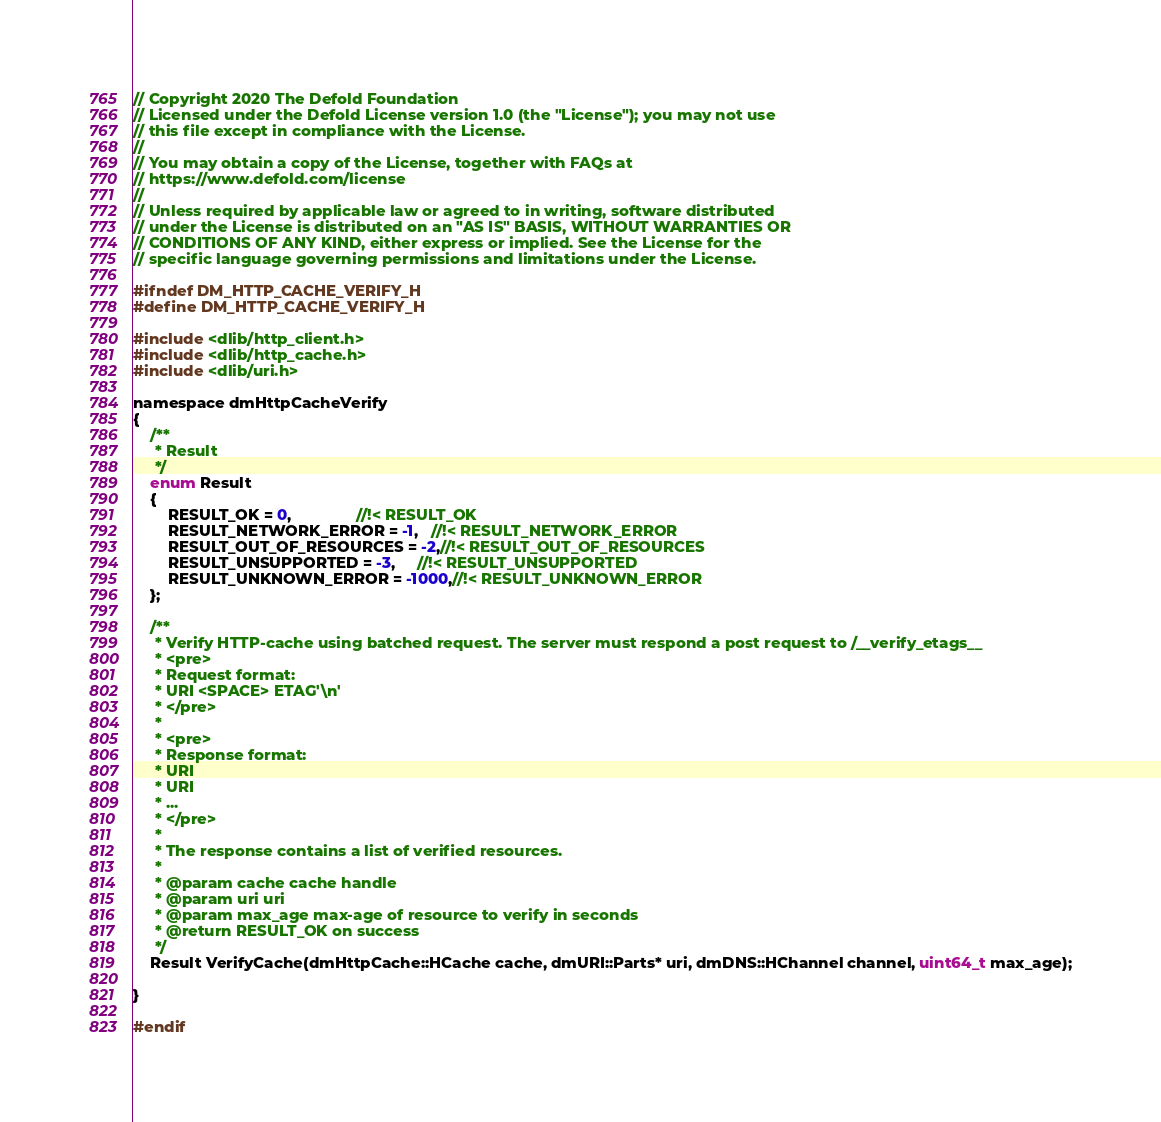<code> <loc_0><loc_0><loc_500><loc_500><_C_>// Copyright 2020 The Defold Foundation
// Licensed under the Defold License version 1.0 (the "License"); you may not use
// this file except in compliance with the License.
// 
// You may obtain a copy of the License, together with FAQs at
// https://www.defold.com/license
// 
// Unless required by applicable law or agreed to in writing, software distributed
// under the License is distributed on an "AS IS" BASIS, WITHOUT WARRANTIES OR
// CONDITIONS OF ANY KIND, either express or implied. See the License for the
// specific language governing permissions and limitations under the License.

#ifndef DM_HTTP_CACHE_VERIFY_H
#define DM_HTTP_CACHE_VERIFY_H

#include <dlib/http_client.h>
#include <dlib/http_cache.h>
#include <dlib/uri.h>

namespace dmHttpCacheVerify
{
    /**
     * Result
     */
    enum Result
    {
        RESULT_OK = 0,               //!< RESULT_OK
        RESULT_NETWORK_ERROR = -1,   //!< RESULT_NETWORK_ERROR
        RESULT_OUT_OF_RESOURCES = -2,//!< RESULT_OUT_OF_RESOURCES
        RESULT_UNSUPPORTED = -3,     //!< RESULT_UNSUPPORTED
        RESULT_UNKNOWN_ERROR = -1000,//!< RESULT_UNKNOWN_ERROR
    };

    /**
     * Verify HTTP-cache using batched request. The server must respond a post request to /__verify_etags__
     * <pre>
     * Request format:
     * URI <SPACE> ETAG'\n'
     * </pre>
     *
     * <pre>
     * Response format:
     * URI
     * URI
     * ...
     * </pre>
     *
     * The response contains a list of verified resources.
     *
     * @param cache cache handle
     * @param uri uri
     * @param max_age max-age of resource to verify in seconds
     * @return RESULT_OK on success
     */
    Result VerifyCache(dmHttpCache::HCache cache, dmURI::Parts* uri, dmDNS::HChannel channel, uint64_t max_age);

}

#endif
</code> 